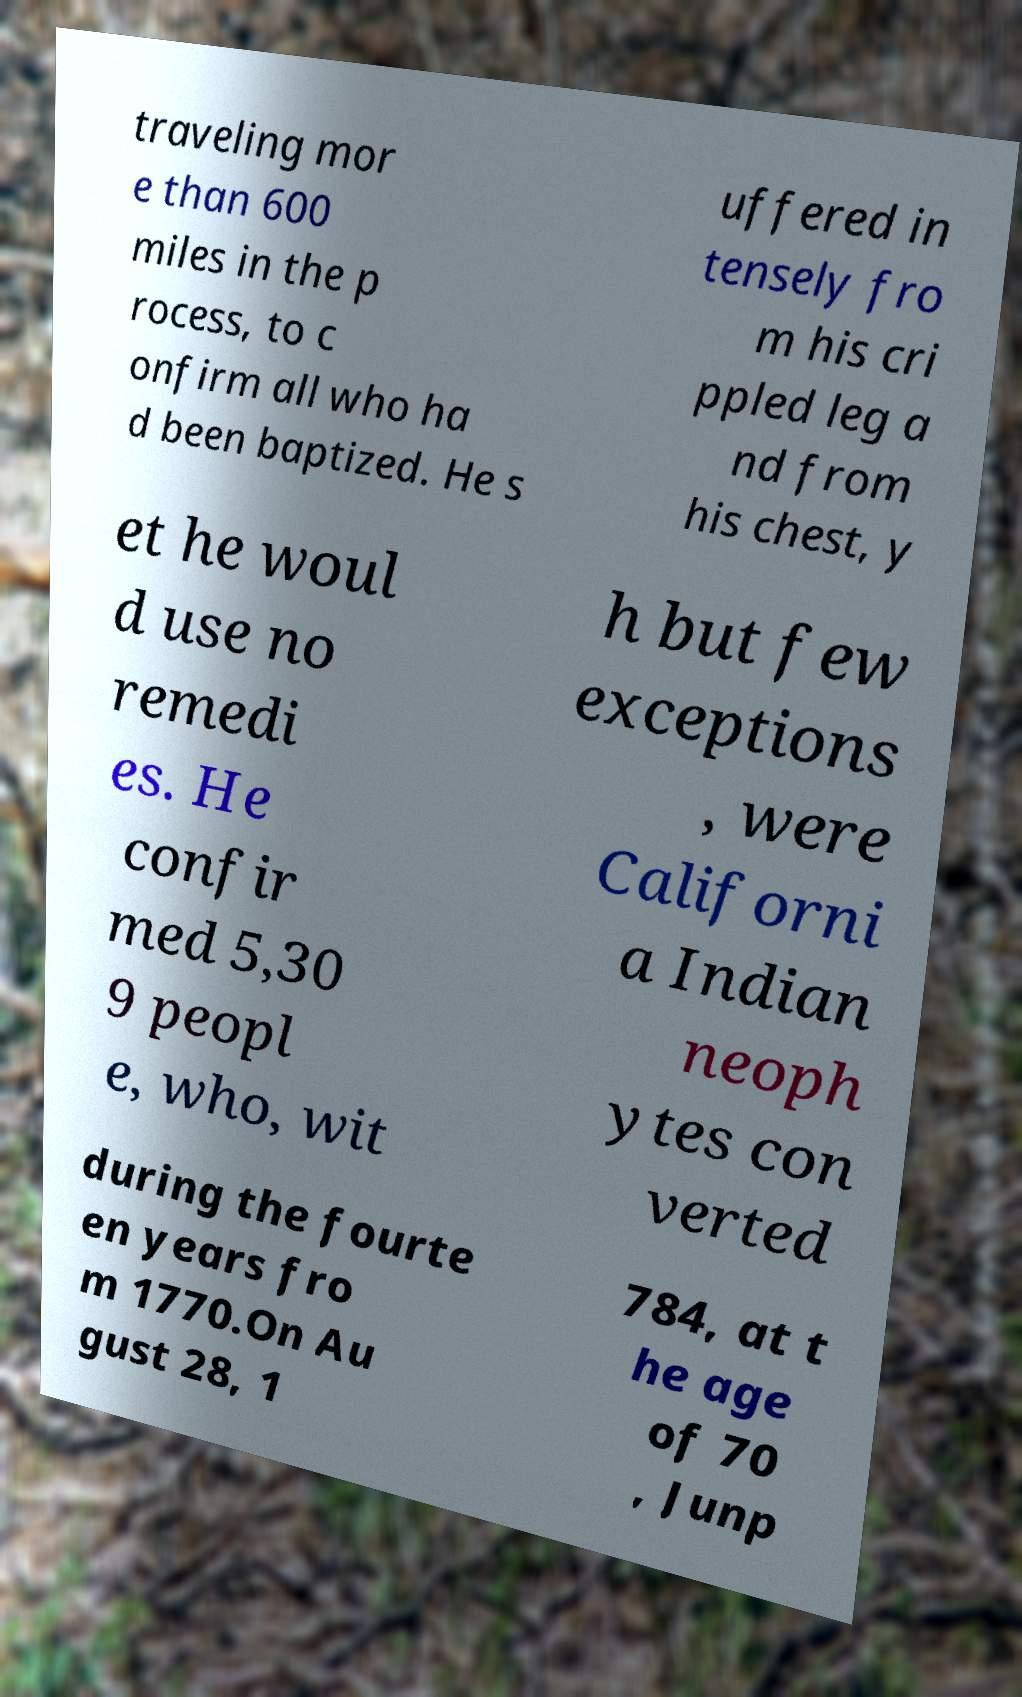Could you extract and type out the text from this image? traveling mor e than 600 miles in the p rocess, to c onfirm all who ha d been baptized. He s uffered in tensely fro m his cri ppled leg a nd from his chest, y et he woul d use no remedi es. He confir med 5,30 9 peopl e, who, wit h but few exceptions , were Californi a Indian neoph ytes con verted during the fourte en years fro m 1770.On Au gust 28, 1 784, at t he age of 70 , Junp 